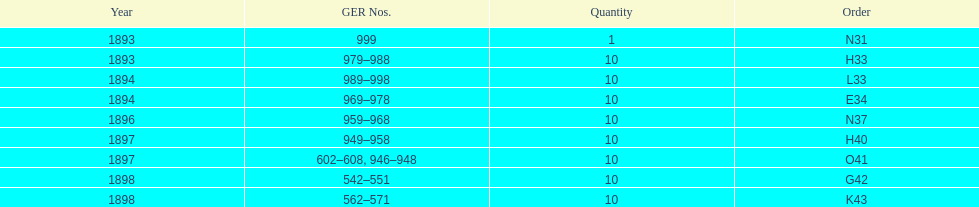How many years are listed? 5. 